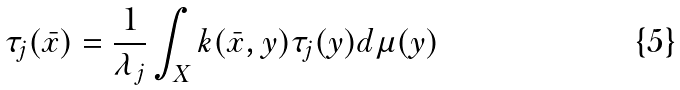<formula> <loc_0><loc_0><loc_500><loc_500>\tau _ { j } ( \bar { x } ) = \frac { 1 } { \lambda _ { j } } \int _ { X } k ( \bar { x } , y ) \tau _ { j } ( y ) d \mu ( y )</formula> 